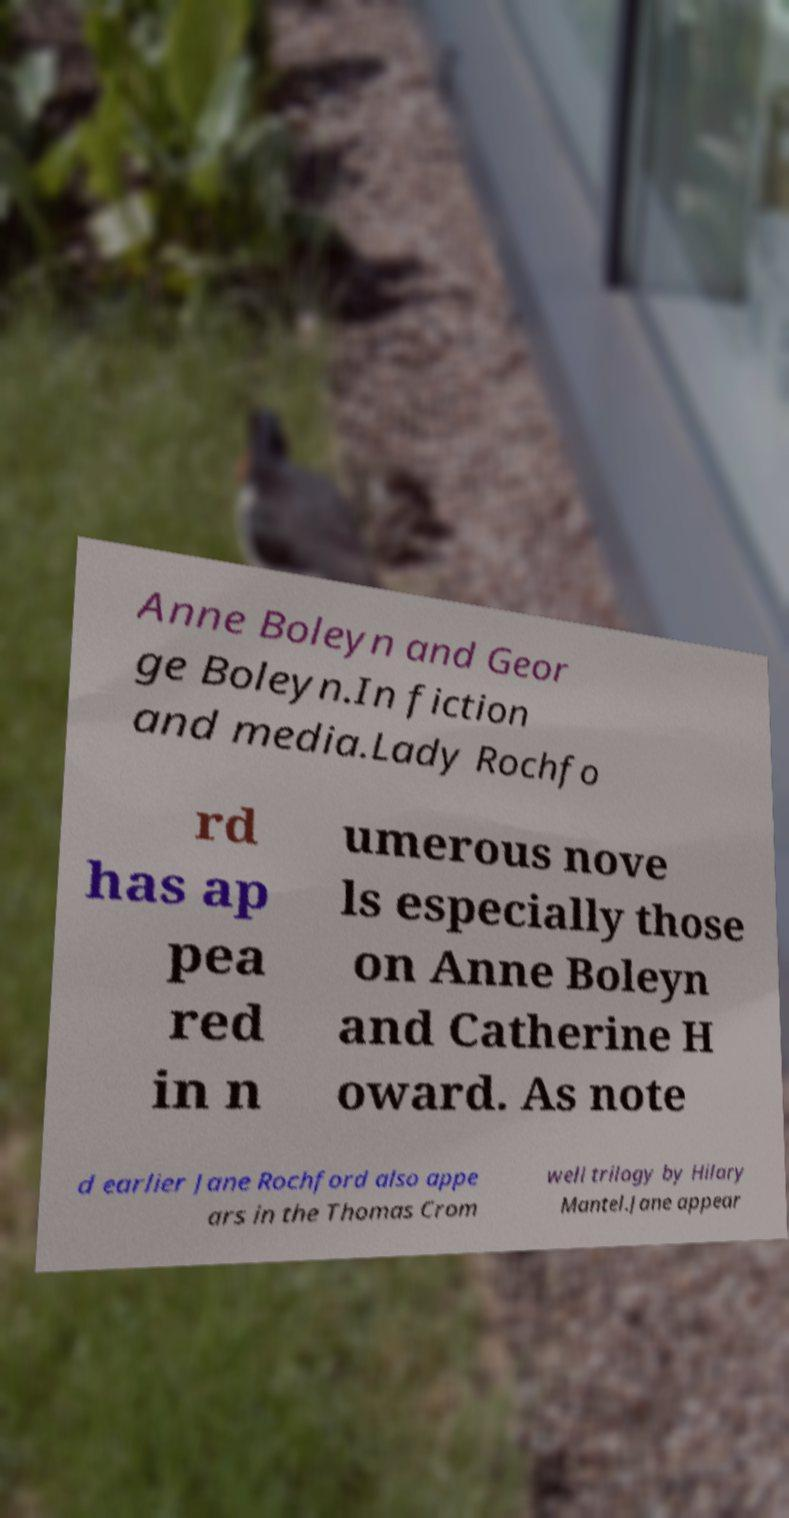There's text embedded in this image that I need extracted. Can you transcribe it verbatim? Anne Boleyn and Geor ge Boleyn.In fiction and media.Lady Rochfo rd has ap pea red in n umerous nove ls especially those on Anne Boleyn and Catherine H oward. As note d earlier Jane Rochford also appe ars in the Thomas Crom well trilogy by Hilary Mantel.Jane appear 